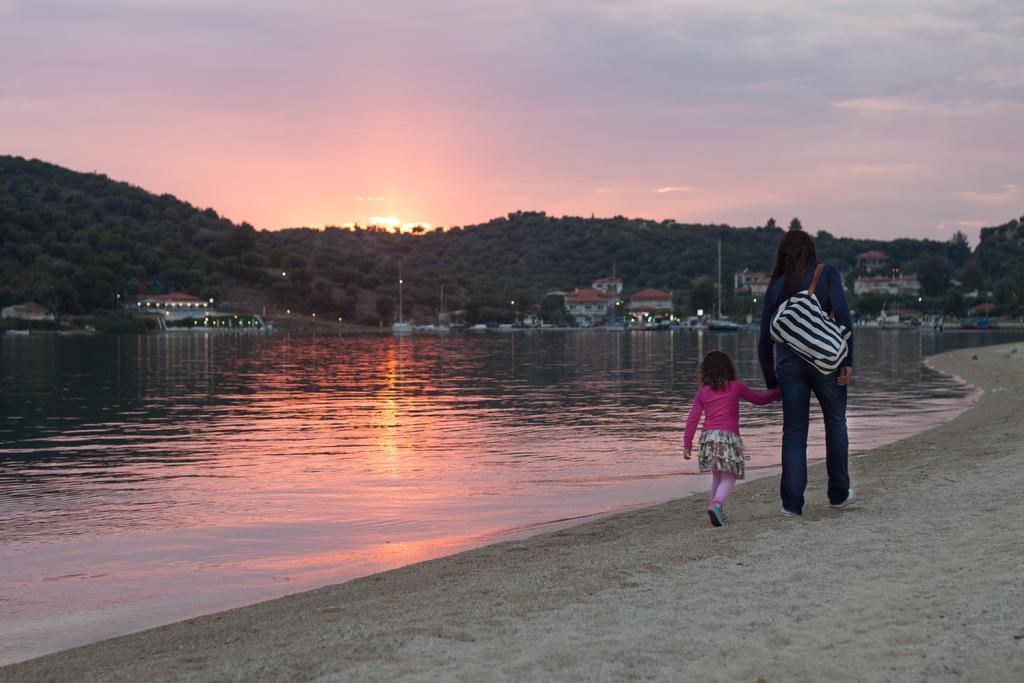Can you describe this image briefly? In the image we can see a woman and a child, wearing clothes and shoes. This woman is carrying a handbag, this is a sand, water, buildings, pole, trees and a sky. 